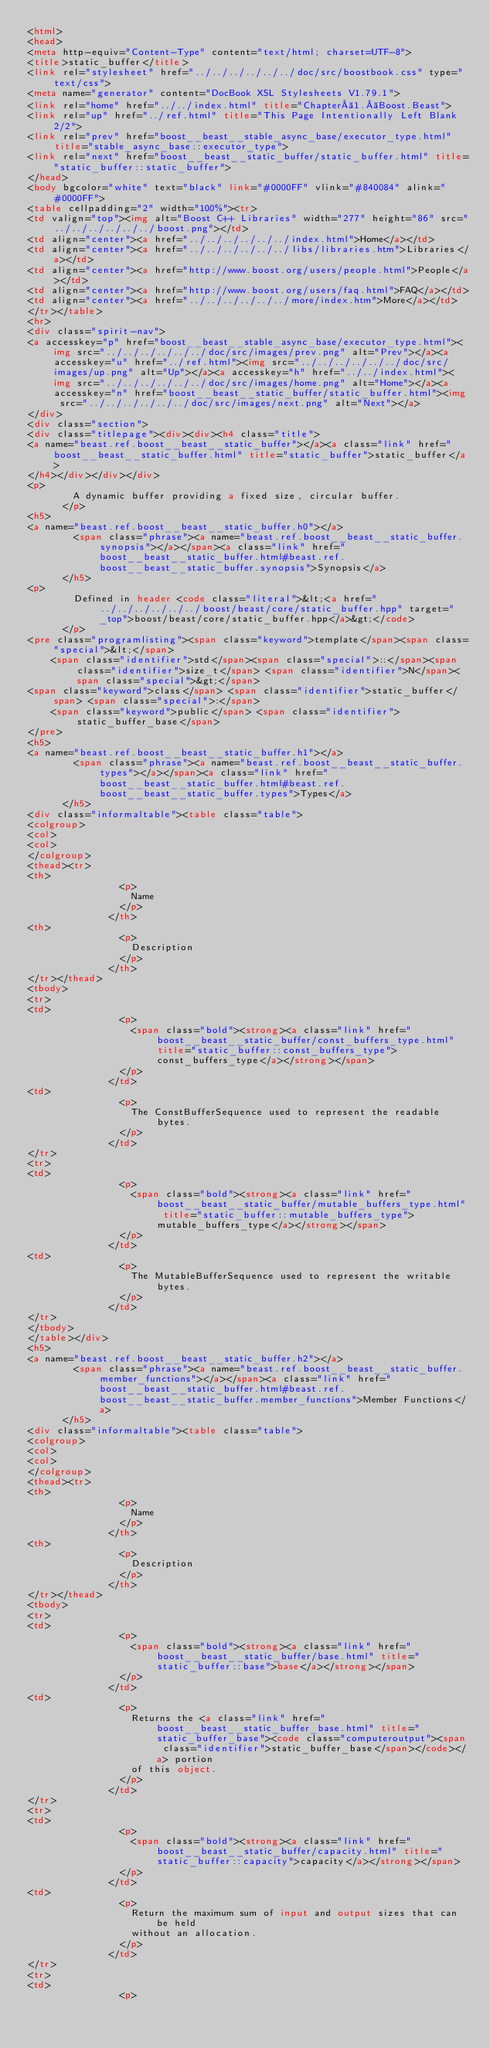<code> <loc_0><loc_0><loc_500><loc_500><_HTML_><html>
<head>
<meta http-equiv="Content-Type" content="text/html; charset=UTF-8">
<title>static_buffer</title>
<link rel="stylesheet" href="../../../../../../doc/src/boostbook.css" type="text/css">
<meta name="generator" content="DocBook XSL Stylesheets V1.79.1">
<link rel="home" href="../../index.html" title="Chapter 1. Boost.Beast">
<link rel="up" href="../ref.html" title="This Page Intentionally Left Blank 2/2">
<link rel="prev" href="boost__beast__stable_async_base/executor_type.html" title="stable_async_base::executor_type">
<link rel="next" href="boost__beast__static_buffer/static_buffer.html" title="static_buffer::static_buffer">
</head>
<body bgcolor="white" text="black" link="#0000FF" vlink="#840084" alink="#0000FF">
<table cellpadding="2" width="100%"><tr>
<td valign="top"><img alt="Boost C++ Libraries" width="277" height="86" src="../../../../../../boost.png"></td>
<td align="center"><a href="../../../../../../index.html">Home</a></td>
<td align="center"><a href="../../../../../../libs/libraries.htm">Libraries</a></td>
<td align="center"><a href="http://www.boost.org/users/people.html">People</a></td>
<td align="center"><a href="http://www.boost.org/users/faq.html">FAQ</a></td>
<td align="center"><a href="../../../../../../more/index.htm">More</a></td>
</tr></table>
<hr>
<div class="spirit-nav">
<a accesskey="p" href="boost__beast__stable_async_base/executor_type.html"><img src="../../../../../../doc/src/images/prev.png" alt="Prev"></a><a accesskey="u" href="../ref.html"><img src="../../../../../../doc/src/images/up.png" alt="Up"></a><a accesskey="h" href="../../index.html"><img src="../../../../../../doc/src/images/home.png" alt="Home"></a><a accesskey="n" href="boost__beast__static_buffer/static_buffer.html"><img src="../../../../../../doc/src/images/next.png" alt="Next"></a>
</div>
<div class="section">
<div class="titlepage"><div><div><h4 class="title">
<a name="beast.ref.boost__beast__static_buffer"></a><a class="link" href="boost__beast__static_buffer.html" title="static_buffer">static_buffer</a>
</h4></div></div></div>
<p>
        A dynamic buffer providing a fixed size, circular buffer.
      </p>
<h5>
<a name="beast.ref.boost__beast__static_buffer.h0"></a>
        <span class="phrase"><a name="beast.ref.boost__beast__static_buffer.synopsis"></a></span><a class="link" href="boost__beast__static_buffer.html#beast.ref.boost__beast__static_buffer.synopsis">Synopsis</a>
      </h5>
<p>
        Defined in header <code class="literal">&lt;<a href="../../../../../../boost/beast/core/static_buffer.hpp" target="_top">boost/beast/core/static_buffer.hpp</a>&gt;</code>
      </p>
<pre class="programlisting"><span class="keyword">template</span><span class="special">&lt;</span>
    <span class="identifier">std</span><span class="special">::</span><span class="identifier">size_t</span> <span class="identifier">N</span><span class="special">&gt;</span>
<span class="keyword">class</span> <span class="identifier">static_buffer</span> <span class="special">:</span>
    <span class="keyword">public</span> <span class="identifier">static_buffer_base</span>
</pre>
<h5>
<a name="beast.ref.boost__beast__static_buffer.h1"></a>
        <span class="phrase"><a name="beast.ref.boost__beast__static_buffer.types"></a></span><a class="link" href="boost__beast__static_buffer.html#beast.ref.boost__beast__static_buffer.types">Types</a>
      </h5>
<div class="informaltable"><table class="table">
<colgroup>
<col>
<col>
</colgroup>
<thead><tr>
<th>
                <p>
                  Name
                </p>
              </th>
<th>
                <p>
                  Description
                </p>
              </th>
</tr></thead>
<tbody>
<tr>
<td>
                <p>
                  <span class="bold"><strong><a class="link" href="boost__beast__static_buffer/const_buffers_type.html" title="static_buffer::const_buffers_type">const_buffers_type</a></strong></span>
                </p>
              </td>
<td>
                <p>
                  The ConstBufferSequence used to represent the readable bytes.
                </p>
              </td>
</tr>
<tr>
<td>
                <p>
                  <span class="bold"><strong><a class="link" href="boost__beast__static_buffer/mutable_buffers_type.html" title="static_buffer::mutable_buffers_type">mutable_buffers_type</a></strong></span>
                </p>
              </td>
<td>
                <p>
                  The MutableBufferSequence used to represent the writable bytes.
                </p>
              </td>
</tr>
</tbody>
</table></div>
<h5>
<a name="beast.ref.boost__beast__static_buffer.h2"></a>
        <span class="phrase"><a name="beast.ref.boost__beast__static_buffer.member_functions"></a></span><a class="link" href="boost__beast__static_buffer.html#beast.ref.boost__beast__static_buffer.member_functions">Member Functions</a>
      </h5>
<div class="informaltable"><table class="table">
<colgroup>
<col>
<col>
</colgroup>
<thead><tr>
<th>
                <p>
                  Name
                </p>
              </th>
<th>
                <p>
                  Description
                </p>
              </th>
</tr></thead>
<tbody>
<tr>
<td>
                <p>
                  <span class="bold"><strong><a class="link" href="boost__beast__static_buffer/base.html" title="static_buffer::base">base</a></strong></span>
                </p>
              </td>
<td>
                <p>
                  Returns the <a class="link" href="boost__beast__static_buffer_base.html" title="static_buffer_base"><code class="computeroutput"><span class="identifier">static_buffer_base</span></code></a> portion
                  of this object.
                </p>
              </td>
</tr>
<tr>
<td>
                <p>
                  <span class="bold"><strong><a class="link" href="boost__beast__static_buffer/capacity.html" title="static_buffer::capacity">capacity</a></strong></span>
                </p>
              </td>
<td>
                <p>
                  Return the maximum sum of input and output sizes that can be held
                  without an allocation.
                </p>
              </td>
</tr>
<tr>
<td>
                <p></code> 